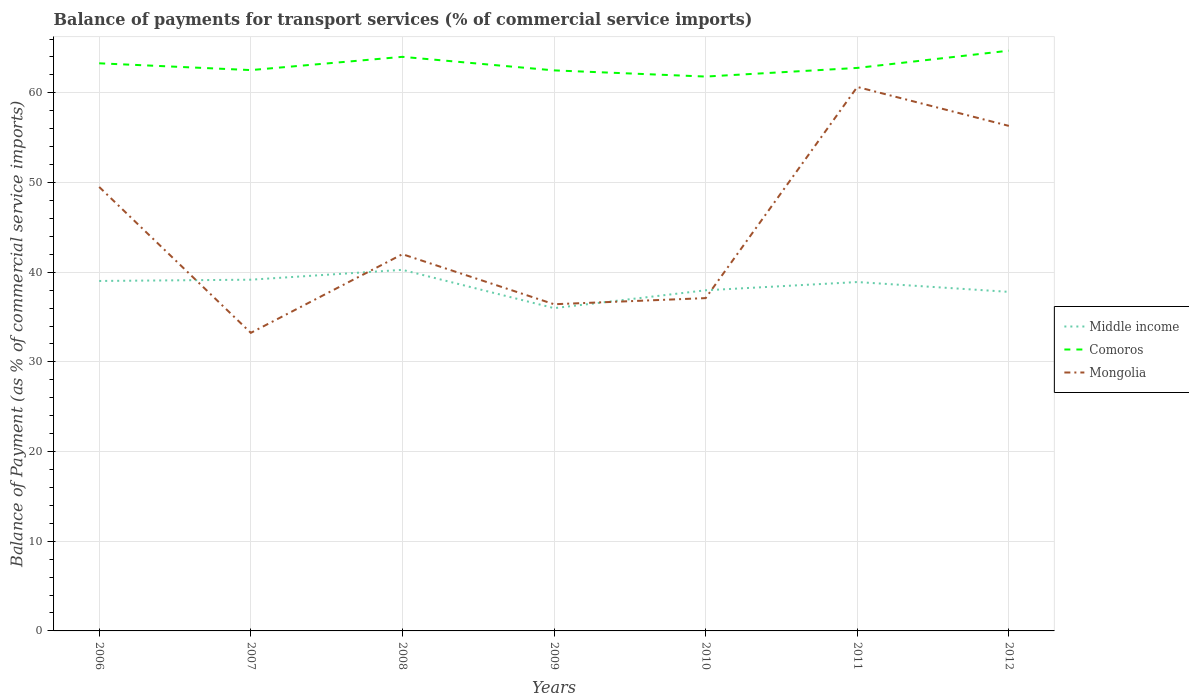How many different coloured lines are there?
Make the answer very short. 3. Does the line corresponding to Comoros intersect with the line corresponding to Mongolia?
Provide a succinct answer. No. Is the number of lines equal to the number of legend labels?
Your response must be concise. Yes. Across all years, what is the maximum balance of payments for transport services in Mongolia?
Ensure brevity in your answer.  33.24. What is the total balance of payments for transport services in Comoros in the graph?
Offer a very short reply. -0.96. What is the difference between the highest and the second highest balance of payments for transport services in Comoros?
Your answer should be very brief. 2.89. What is the difference between the highest and the lowest balance of payments for transport services in Middle income?
Your answer should be very brief. 4. What is the difference between two consecutive major ticks on the Y-axis?
Give a very brief answer. 10. Does the graph contain grids?
Provide a short and direct response. Yes. Where does the legend appear in the graph?
Offer a terse response. Center right. How many legend labels are there?
Give a very brief answer. 3. How are the legend labels stacked?
Your answer should be very brief. Vertical. What is the title of the graph?
Give a very brief answer. Balance of payments for transport services (% of commercial service imports). Does "Croatia" appear as one of the legend labels in the graph?
Your answer should be very brief. No. What is the label or title of the Y-axis?
Offer a very short reply. Balance of Payment (as % of commercial service imports). What is the Balance of Payment (as % of commercial service imports) of Middle income in 2006?
Ensure brevity in your answer.  39.02. What is the Balance of Payment (as % of commercial service imports) in Comoros in 2006?
Provide a short and direct response. 63.3. What is the Balance of Payment (as % of commercial service imports) in Mongolia in 2006?
Make the answer very short. 49.51. What is the Balance of Payment (as % of commercial service imports) of Middle income in 2007?
Provide a short and direct response. 39.17. What is the Balance of Payment (as % of commercial service imports) of Comoros in 2007?
Offer a terse response. 62.54. What is the Balance of Payment (as % of commercial service imports) in Mongolia in 2007?
Your answer should be very brief. 33.24. What is the Balance of Payment (as % of commercial service imports) of Middle income in 2008?
Make the answer very short. 40.27. What is the Balance of Payment (as % of commercial service imports) of Comoros in 2008?
Ensure brevity in your answer.  64.02. What is the Balance of Payment (as % of commercial service imports) of Mongolia in 2008?
Your answer should be very brief. 42.01. What is the Balance of Payment (as % of commercial service imports) in Middle income in 2009?
Provide a short and direct response. 35.99. What is the Balance of Payment (as % of commercial service imports) in Comoros in 2009?
Offer a very short reply. 62.51. What is the Balance of Payment (as % of commercial service imports) of Mongolia in 2009?
Provide a short and direct response. 36.43. What is the Balance of Payment (as % of commercial service imports) of Middle income in 2010?
Make the answer very short. 37.98. What is the Balance of Payment (as % of commercial service imports) in Comoros in 2010?
Ensure brevity in your answer.  61.82. What is the Balance of Payment (as % of commercial service imports) of Mongolia in 2010?
Give a very brief answer. 37.11. What is the Balance of Payment (as % of commercial service imports) in Middle income in 2011?
Provide a short and direct response. 38.9. What is the Balance of Payment (as % of commercial service imports) of Comoros in 2011?
Offer a very short reply. 62.78. What is the Balance of Payment (as % of commercial service imports) of Mongolia in 2011?
Ensure brevity in your answer.  60.66. What is the Balance of Payment (as % of commercial service imports) of Middle income in 2012?
Your response must be concise. 37.81. What is the Balance of Payment (as % of commercial service imports) of Comoros in 2012?
Provide a succinct answer. 64.7. What is the Balance of Payment (as % of commercial service imports) of Mongolia in 2012?
Offer a very short reply. 56.32. Across all years, what is the maximum Balance of Payment (as % of commercial service imports) in Middle income?
Offer a terse response. 40.27. Across all years, what is the maximum Balance of Payment (as % of commercial service imports) of Comoros?
Offer a terse response. 64.7. Across all years, what is the maximum Balance of Payment (as % of commercial service imports) in Mongolia?
Your answer should be very brief. 60.66. Across all years, what is the minimum Balance of Payment (as % of commercial service imports) of Middle income?
Keep it short and to the point. 35.99. Across all years, what is the minimum Balance of Payment (as % of commercial service imports) in Comoros?
Keep it short and to the point. 61.82. Across all years, what is the minimum Balance of Payment (as % of commercial service imports) in Mongolia?
Your response must be concise. 33.24. What is the total Balance of Payment (as % of commercial service imports) in Middle income in the graph?
Provide a succinct answer. 269.14. What is the total Balance of Payment (as % of commercial service imports) in Comoros in the graph?
Provide a succinct answer. 441.66. What is the total Balance of Payment (as % of commercial service imports) in Mongolia in the graph?
Keep it short and to the point. 315.27. What is the difference between the Balance of Payment (as % of commercial service imports) in Middle income in 2006 and that in 2007?
Your response must be concise. -0.14. What is the difference between the Balance of Payment (as % of commercial service imports) in Comoros in 2006 and that in 2007?
Your answer should be very brief. 0.76. What is the difference between the Balance of Payment (as % of commercial service imports) of Mongolia in 2006 and that in 2007?
Give a very brief answer. 16.27. What is the difference between the Balance of Payment (as % of commercial service imports) of Middle income in 2006 and that in 2008?
Offer a very short reply. -1.24. What is the difference between the Balance of Payment (as % of commercial service imports) of Comoros in 2006 and that in 2008?
Your answer should be compact. -0.72. What is the difference between the Balance of Payment (as % of commercial service imports) in Mongolia in 2006 and that in 2008?
Your answer should be very brief. 7.5. What is the difference between the Balance of Payment (as % of commercial service imports) of Middle income in 2006 and that in 2009?
Ensure brevity in your answer.  3.03. What is the difference between the Balance of Payment (as % of commercial service imports) in Comoros in 2006 and that in 2009?
Offer a terse response. 0.79. What is the difference between the Balance of Payment (as % of commercial service imports) of Mongolia in 2006 and that in 2009?
Provide a succinct answer. 13.08. What is the difference between the Balance of Payment (as % of commercial service imports) in Middle income in 2006 and that in 2010?
Offer a very short reply. 1.04. What is the difference between the Balance of Payment (as % of commercial service imports) in Comoros in 2006 and that in 2010?
Make the answer very short. 1.48. What is the difference between the Balance of Payment (as % of commercial service imports) in Mongolia in 2006 and that in 2010?
Offer a very short reply. 12.39. What is the difference between the Balance of Payment (as % of commercial service imports) of Middle income in 2006 and that in 2011?
Provide a succinct answer. 0.12. What is the difference between the Balance of Payment (as % of commercial service imports) in Comoros in 2006 and that in 2011?
Offer a very short reply. 0.52. What is the difference between the Balance of Payment (as % of commercial service imports) of Mongolia in 2006 and that in 2011?
Offer a terse response. -11.15. What is the difference between the Balance of Payment (as % of commercial service imports) in Middle income in 2006 and that in 2012?
Keep it short and to the point. 1.22. What is the difference between the Balance of Payment (as % of commercial service imports) in Comoros in 2006 and that in 2012?
Ensure brevity in your answer.  -1.41. What is the difference between the Balance of Payment (as % of commercial service imports) in Mongolia in 2006 and that in 2012?
Your answer should be very brief. -6.81. What is the difference between the Balance of Payment (as % of commercial service imports) of Middle income in 2007 and that in 2008?
Your answer should be very brief. -1.1. What is the difference between the Balance of Payment (as % of commercial service imports) in Comoros in 2007 and that in 2008?
Ensure brevity in your answer.  -1.48. What is the difference between the Balance of Payment (as % of commercial service imports) in Mongolia in 2007 and that in 2008?
Make the answer very short. -8.77. What is the difference between the Balance of Payment (as % of commercial service imports) of Middle income in 2007 and that in 2009?
Your answer should be compact. 3.17. What is the difference between the Balance of Payment (as % of commercial service imports) of Comoros in 2007 and that in 2009?
Offer a very short reply. 0.03. What is the difference between the Balance of Payment (as % of commercial service imports) in Mongolia in 2007 and that in 2009?
Offer a terse response. -3.19. What is the difference between the Balance of Payment (as % of commercial service imports) of Middle income in 2007 and that in 2010?
Keep it short and to the point. 1.18. What is the difference between the Balance of Payment (as % of commercial service imports) of Comoros in 2007 and that in 2010?
Offer a very short reply. 0.72. What is the difference between the Balance of Payment (as % of commercial service imports) of Mongolia in 2007 and that in 2010?
Your answer should be very brief. -3.87. What is the difference between the Balance of Payment (as % of commercial service imports) in Middle income in 2007 and that in 2011?
Offer a terse response. 0.26. What is the difference between the Balance of Payment (as % of commercial service imports) in Comoros in 2007 and that in 2011?
Give a very brief answer. -0.24. What is the difference between the Balance of Payment (as % of commercial service imports) of Mongolia in 2007 and that in 2011?
Offer a very short reply. -27.42. What is the difference between the Balance of Payment (as % of commercial service imports) of Middle income in 2007 and that in 2012?
Provide a succinct answer. 1.36. What is the difference between the Balance of Payment (as % of commercial service imports) of Comoros in 2007 and that in 2012?
Your response must be concise. -2.16. What is the difference between the Balance of Payment (as % of commercial service imports) of Mongolia in 2007 and that in 2012?
Your answer should be compact. -23.08. What is the difference between the Balance of Payment (as % of commercial service imports) of Middle income in 2008 and that in 2009?
Give a very brief answer. 4.27. What is the difference between the Balance of Payment (as % of commercial service imports) of Comoros in 2008 and that in 2009?
Ensure brevity in your answer.  1.51. What is the difference between the Balance of Payment (as % of commercial service imports) in Mongolia in 2008 and that in 2009?
Your answer should be very brief. 5.58. What is the difference between the Balance of Payment (as % of commercial service imports) of Middle income in 2008 and that in 2010?
Make the answer very short. 2.28. What is the difference between the Balance of Payment (as % of commercial service imports) in Comoros in 2008 and that in 2010?
Provide a succinct answer. 2.2. What is the difference between the Balance of Payment (as % of commercial service imports) of Mongolia in 2008 and that in 2010?
Make the answer very short. 4.9. What is the difference between the Balance of Payment (as % of commercial service imports) of Middle income in 2008 and that in 2011?
Provide a short and direct response. 1.36. What is the difference between the Balance of Payment (as % of commercial service imports) of Comoros in 2008 and that in 2011?
Provide a short and direct response. 1.24. What is the difference between the Balance of Payment (as % of commercial service imports) in Mongolia in 2008 and that in 2011?
Provide a succinct answer. -18.65. What is the difference between the Balance of Payment (as % of commercial service imports) of Middle income in 2008 and that in 2012?
Your answer should be very brief. 2.46. What is the difference between the Balance of Payment (as % of commercial service imports) in Comoros in 2008 and that in 2012?
Offer a terse response. -0.69. What is the difference between the Balance of Payment (as % of commercial service imports) in Mongolia in 2008 and that in 2012?
Your answer should be very brief. -14.31. What is the difference between the Balance of Payment (as % of commercial service imports) of Middle income in 2009 and that in 2010?
Provide a succinct answer. -1.99. What is the difference between the Balance of Payment (as % of commercial service imports) in Comoros in 2009 and that in 2010?
Ensure brevity in your answer.  0.69. What is the difference between the Balance of Payment (as % of commercial service imports) of Mongolia in 2009 and that in 2010?
Keep it short and to the point. -0.68. What is the difference between the Balance of Payment (as % of commercial service imports) in Middle income in 2009 and that in 2011?
Ensure brevity in your answer.  -2.91. What is the difference between the Balance of Payment (as % of commercial service imports) of Comoros in 2009 and that in 2011?
Give a very brief answer. -0.27. What is the difference between the Balance of Payment (as % of commercial service imports) in Mongolia in 2009 and that in 2011?
Your response must be concise. -24.23. What is the difference between the Balance of Payment (as % of commercial service imports) of Middle income in 2009 and that in 2012?
Your answer should be compact. -1.81. What is the difference between the Balance of Payment (as % of commercial service imports) in Comoros in 2009 and that in 2012?
Your answer should be compact. -2.2. What is the difference between the Balance of Payment (as % of commercial service imports) in Mongolia in 2009 and that in 2012?
Your response must be concise. -19.89. What is the difference between the Balance of Payment (as % of commercial service imports) in Middle income in 2010 and that in 2011?
Make the answer very short. -0.92. What is the difference between the Balance of Payment (as % of commercial service imports) in Comoros in 2010 and that in 2011?
Your response must be concise. -0.96. What is the difference between the Balance of Payment (as % of commercial service imports) of Mongolia in 2010 and that in 2011?
Keep it short and to the point. -23.55. What is the difference between the Balance of Payment (as % of commercial service imports) of Middle income in 2010 and that in 2012?
Make the answer very short. 0.18. What is the difference between the Balance of Payment (as % of commercial service imports) of Comoros in 2010 and that in 2012?
Your answer should be compact. -2.89. What is the difference between the Balance of Payment (as % of commercial service imports) in Mongolia in 2010 and that in 2012?
Your response must be concise. -19.21. What is the difference between the Balance of Payment (as % of commercial service imports) in Middle income in 2011 and that in 2012?
Provide a succinct answer. 1.1. What is the difference between the Balance of Payment (as % of commercial service imports) of Comoros in 2011 and that in 2012?
Give a very brief answer. -1.92. What is the difference between the Balance of Payment (as % of commercial service imports) of Mongolia in 2011 and that in 2012?
Your answer should be very brief. 4.34. What is the difference between the Balance of Payment (as % of commercial service imports) of Middle income in 2006 and the Balance of Payment (as % of commercial service imports) of Comoros in 2007?
Provide a short and direct response. -23.52. What is the difference between the Balance of Payment (as % of commercial service imports) in Middle income in 2006 and the Balance of Payment (as % of commercial service imports) in Mongolia in 2007?
Provide a short and direct response. 5.79. What is the difference between the Balance of Payment (as % of commercial service imports) of Comoros in 2006 and the Balance of Payment (as % of commercial service imports) of Mongolia in 2007?
Your answer should be compact. 30.06. What is the difference between the Balance of Payment (as % of commercial service imports) in Middle income in 2006 and the Balance of Payment (as % of commercial service imports) in Comoros in 2008?
Offer a very short reply. -24.99. What is the difference between the Balance of Payment (as % of commercial service imports) of Middle income in 2006 and the Balance of Payment (as % of commercial service imports) of Mongolia in 2008?
Your answer should be very brief. -2.98. What is the difference between the Balance of Payment (as % of commercial service imports) in Comoros in 2006 and the Balance of Payment (as % of commercial service imports) in Mongolia in 2008?
Ensure brevity in your answer.  21.29. What is the difference between the Balance of Payment (as % of commercial service imports) of Middle income in 2006 and the Balance of Payment (as % of commercial service imports) of Comoros in 2009?
Offer a very short reply. -23.48. What is the difference between the Balance of Payment (as % of commercial service imports) in Middle income in 2006 and the Balance of Payment (as % of commercial service imports) in Mongolia in 2009?
Keep it short and to the point. 2.6. What is the difference between the Balance of Payment (as % of commercial service imports) in Comoros in 2006 and the Balance of Payment (as % of commercial service imports) in Mongolia in 2009?
Give a very brief answer. 26.87. What is the difference between the Balance of Payment (as % of commercial service imports) of Middle income in 2006 and the Balance of Payment (as % of commercial service imports) of Comoros in 2010?
Your response must be concise. -22.79. What is the difference between the Balance of Payment (as % of commercial service imports) of Middle income in 2006 and the Balance of Payment (as % of commercial service imports) of Mongolia in 2010?
Give a very brief answer. 1.91. What is the difference between the Balance of Payment (as % of commercial service imports) in Comoros in 2006 and the Balance of Payment (as % of commercial service imports) in Mongolia in 2010?
Provide a short and direct response. 26.18. What is the difference between the Balance of Payment (as % of commercial service imports) of Middle income in 2006 and the Balance of Payment (as % of commercial service imports) of Comoros in 2011?
Give a very brief answer. -23.76. What is the difference between the Balance of Payment (as % of commercial service imports) of Middle income in 2006 and the Balance of Payment (as % of commercial service imports) of Mongolia in 2011?
Ensure brevity in your answer.  -21.63. What is the difference between the Balance of Payment (as % of commercial service imports) in Comoros in 2006 and the Balance of Payment (as % of commercial service imports) in Mongolia in 2011?
Make the answer very short. 2.64. What is the difference between the Balance of Payment (as % of commercial service imports) of Middle income in 2006 and the Balance of Payment (as % of commercial service imports) of Comoros in 2012?
Offer a terse response. -25.68. What is the difference between the Balance of Payment (as % of commercial service imports) in Middle income in 2006 and the Balance of Payment (as % of commercial service imports) in Mongolia in 2012?
Give a very brief answer. -17.29. What is the difference between the Balance of Payment (as % of commercial service imports) in Comoros in 2006 and the Balance of Payment (as % of commercial service imports) in Mongolia in 2012?
Make the answer very short. 6.98. What is the difference between the Balance of Payment (as % of commercial service imports) of Middle income in 2007 and the Balance of Payment (as % of commercial service imports) of Comoros in 2008?
Provide a succinct answer. -24.85. What is the difference between the Balance of Payment (as % of commercial service imports) of Middle income in 2007 and the Balance of Payment (as % of commercial service imports) of Mongolia in 2008?
Your answer should be compact. -2.84. What is the difference between the Balance of Payment (as % of commercial service imports) in Comoros in 2007 and the Balance of Payment (as % of commercial service imports) in Mongolia in 2008?
Ensure brevity in your answer.  20.53. What is the difference between the Balance of Payment (as % of commercial service imports) in Middle income in 2007 and the Balance of Payment (as % of commercial service imports) in Comoros in 2009?
Keep it short and to the point. -23.34. What is the difference between the Balance of Payment (as % of commercial service imports) in Middle income in 2007 and the Balance of Payment (as % of commercial service imports) in Mongolia in 2009?
Offer a terse response. 2.74. What is the difference between the Balance of Payment (as % of commercial service imports) in Comoros in 2007 and the Balance of Payment (as % of commercial service imports) in Mongolia in 2009?
Offer a terse response. 26.11. What is the difference between the Balance of Payment (as % of commercial service imports) in Middle income in 2007 and the Balance of Payment (as % of commercial service imports) in Comoros in 2010?
Keep it short and to the point. -22.65. What is the difference between the Balance of Payment (as % of commercial service imports) in Middle income in 2007 and the Balance of Payment (as % of commercial service imports) in Mongolia in 2010?
Make the answer very short. 2.05. What is the difference between the Balance of Payment (as % of commercial service imports) of Comoros in 2007 and the Balance of Payment (as % of commercial service imports) of Mongolia in 2010?
Provide a succinct answer. 25.43. What is the difference between the Balance of Payment (as % of commercial service imports) in Middle income in 2007 and the Balance of Payment (as % of commercial service imports) in Comoros in 2011?
Provide a succinct answer. -23.61. What is the difference between the Balance of Payment (as % of commercial service imports) of Middle income in 2007 and the Balance of Payment (as % of commercial service imports) of Mongolia in 2011?
Ensure brevity in your answer.  -21.49. What is the difference between the Balance of Payment (as % of commercial service imports) in Comoros in 2007 and the Balance of Payment (as % of commercial service imports) in Mongolia in 2011?
Offer a very short reply. 1.88. What is the difference between the Balance of Payment (as % of commercial service imports) of Middle income in 2007 and the Balance of Payment (as % of commercial service imports) of Comoros in 2012?
Offer a terse response. -25.54. What is the difference between the Balance of Payment (as % of commercial service imports) of Middle income in 2007 and the Balance of Payment (as % of commercial service imports) of Mongolia in 2012?
Provide a short and direct response. -17.15. What is the difference between the Balance of Payment (as % of commercial service imports) of Comoros in 2007 and the Balance of Payment (as % of commercial service imports) of Mongolia in 2012?
Offer a terse response. 6.22. What is the difference between the Balance of Payment (as % of commercial service imports) of Middle income in 2008 and the Balance of Payment (as % of commercial service imports) of Comoros in 2009?
Ensure brevity in your answer.  -22.24. What is the difference between the Balance of Payment (as % of commercial service imports) in Middle income in 2008 and the Balance of Payment (as % of commercial service imports) in Mongolia in 2009?
Keep it short and to the point. 3.84. What is the difference between the Balance of Payment (as % of commercial service imports) of Comoros in 2008 and the Balance of Payment (as % of commercial service imports) of Mongolia in 2009?
Your response must be concise. 27.59. What is the difference between the Balance of Payment (as % of commercial service imports) in Middle income in 2008 and the Balance of Payment (as % of commercial service imports) in Comoros in 2010?
Provide a succinct answer. -21.55. What is the difference between the Balance of Payment (as % of commercial service imports) of Middle income in 2008 and the Balance of Payment (as % of commercial service imports) of Mongolia in 2010?
Offer a very short reply. 3.15. What is the difference between the Balance of Payment (as % of commercial service imports) in Comoros in 2008 and the Balance of Payment (as % of commercial service imports) in Mongolia in 2010?
Your answer should be compact. 26.91. What is the difference between the Balance of Payment (as % of commercial service imports) of Middle income in 2008 and the Balance of Payment (as % of commercial service imports) of Comoros in 2011?
Keep it short and to the point. -22.52. What is the difference between the Balance of Payment (as % of commercial service imports) in Middle income in 2008 and the Balance of Payment (as % of commercial service imports) in Mongolia in 2011?
Give a very brief answer. -20.39. What is the difference between the Balance of Payment (as % of commercial service imports) in Comoros in 2008 and the Balance of Payment (as % of commercial service imports) in Mongolia in 2011?
Ensure brevity in your answer.  3.36. What is the difference between the Balance of Payment (as % of commercial service imports) of Middle income in 2008 and the Balance of Payment (as % of commercial service imports) of Comoros in 2012?
Ensure brevity in your answer.  -24.44. What is the difference between the Balance of Payment (as % of commercial service imports) in Middle income in 2008 and the Balance of Payment (as % of commercial service imports) in Mongolia in 2012?
Your answer should be compact. -16.05. What is the difference between the Balance of Payment (as % of commercial service imports) in Comoros in 2008 and the Balance of Payment (as % of commercial service imports) in Mongolia in 2012?
Keep it short and to the point. 7.7. What is the difference between the Balance of Payment (as % of commercial service imports) in Middle income in 2009 and the Balance of Payment (as % of commercial service imports) in Comoros in 2010?
Your answer should be very brief. -25.82. What is the difference between the Balance of Payment (as % of commercial service imports) of Middle income in 2009 and the Balance of Payment (as % of commercial service imports) of Mongolia in 2010?
Provide a short and direct response. -1.12. What is the difference between the Balance of Payment (as % of commercial service imports) of Comoros in 2009 and the Balance of Payment (as % of commercial service imports) of Mongolia in 2010?
Your answer should be compact. 25.39. What is the difference between the Balance of Payment (as % of commercial service imports) of Middle income in 2009 and the Balance of Payment (as % of commercial service imports) of Comoros in 2011?
Offer a terse response. -26.79. What is the difference between the Balance of Payment (as % of commercial service imports) of Middle income in 2009 and the Balance of Payment (as % of commercial service imports) of Mongolia in 2011?
Your answer should be very brief. -24.66. What is the difference between the Balance of Payment (as % of commercial service imports) in Comoros in 2009 and the Balance of Payment (as % of commercial service imports) in Mongolia in 2011?
Your answer should be compact. 1.85. What is the difference between the Balance of Payment (as % of commercial service imports) in Middle income in 2009 and the Balance of Payment (as % of commercial service imports) in Comoros in 2012?
Make the answer very short. -28.71. What is the difference between the Balance of Payment (as % of commercial service imports) in Middle income in 2009 and the Balance of Payment (as % of commercial service imports) in Mongolia in 2012?
Provide a succinct answer. -20.32. What is the difference between the Balance of Payment (as % of commercial service imports) in Comoros in 2009 and the Balance of Payment (as % of commercial service imports) in Mongolia in 2012?
Make the answer very short. 6.19. What is the difference between the Balance of Payment (as % of commercial service imports) of Middle income in 2010 and the Balance of Payment (as % of commercial service imports) of Comoros in 2011?
Give a very brief answer. -24.8. What is the difference between the Balance of Payment (as % of commercial service imports) of Middle income in 2010 and the Balance of Payment (as % of commercial service imports) of Mongolia in 2011?
Your answer should be very brief. -22.67. What is the difference between the Balance of Payment (as % of commercial service imports) in Comoros in 2010 and the Balance of Payment (as % of commercial service imports) in Mongolia in 2011?
Your answer should be very brief. 1.16. What is the difference between the Balance of Payment (as % of commercial service imports) in Middle income in 2010 and the Balance of Payment (as % of commercial service imports) in Comoros in 2012?
Give a very brief answer. -26.72. What is the difference between the Balance of Payment (as % of commercial service imports) of Middle income in 2010 and the Balance of Payment (as % of commercial service imports) of Mongolia in 2012?
Give a very brief answer. -18.33. What is the difference between the Balance of Payment (as % of commercial service imports) of Comoros in 2010 and the Balance of Payment (as % of commercial service imports) of Mongolia in 2012?
Provide a short and direct response. 5.5. What is the difference between the Balance of Payment (as % of commercial service imports) in Middle income in 2011 and the Balance of Payment (as % of commercial service imports) in Comoros in 2012?
Give a very brief answer. -25.8. What is the difference between the Balance of Payment (as % of commercial service imports) of Middle income in 2011 and the Balance of Payment (as % of commercial service imports) of Mongolia in 2012?
Keep it short and to the point. -17.41. What is the difference between the Balance of Payment (as % of commercial service imports) in Comoros in 2011 and the Balance of Payment (as % of commercial service imports) in Mongolia in 2012?
Your response must be concise. 6.46. What is the average Balance of Payment (as % of commercial service imports) in Middle income per year?
Give a very brief answer. 38.45. What is the average Balance of Payment (as % of commercial service imports) in Comoros per year?
Provide a short and direct response. 63.09. What is the average Balance of Payment (as % of commercial service imports) of Mongolia per year?
Keep it short and to the point. 45.04. In the year 2006, what is the difference between the Balance of Payment (as % of commercial service imports) of Middle income and Balance of Payment (as % of commercial service imports) of Comoros?
Ensure brevity in your answer.  -24.27. In the year 2006, what is the difference between the Balance of Payment (as % of commercial service imports) in Middle income and Balance of Payment (as % of commercial service imports) in Mongolia?
Offer a terse response. -10.48. In the year 2006, what is the difference between the Balance of Payment (as % of commercial service imports) of Comoros and Balance of Payment (as % of commercial service imports) of Mongolia?
Your response must be concise. 13.79. In the year 2007, what is the difference between the Balance of Payment (as % of commercial service imports) of Middle income and Balance of Payment (as % of commercial service imports) of Comoros?
Your answer should be very brief. -23.37. In the year 2007, what is the difference between the Balance of Payment (as % of commercial service imports) in Middle income and Balance of Payment (as % of commercial service imports) in Mongolia?
Keep it short and to the point. 5.93. In the year 2007, what is the difference between the Balance of Payment (as % of commercial service imports) of Comoros and Balance of Payment (as % of commercial service imports) of Mongolia?
Your response must be concise. 29.3. In the year 2008, what is the difference between the Balance of Payment (as % of commercial service imports) in Middle income and Balance of Payment (as % of commercial service imports) in Comoros?
Provide a succinct answer. -23.75. In the year 2008, what is the difference between the Balance of Payment (as % of commercial service imports) of Middle income and Balance of Payment (as % of commercial service imports) of Mongolia?
Your answer should be compact. -1.74. In the year 2008, what is the difference between the Balance of Payment (as % of commercial service imports) in Comoros and Balance of Payment (as % of commercial service imports) in Mongolia?
Give a very brief answer. 22.01. In the year 2009, what is the difference between the Balance of Payment (as % of commercial service imports) of Middle income and Balance of Payment (as % of commercial service imports) of Comoros?
Your response must be concise. -26.51. In the year 2009, what is the difference between the Balance of Payment (as % of commercial service imports) in Middle income and Balance of Payment (as % of commercial service imports) in Mongolia?
Ensure brevity in your answer.  -0.44. In the year 2009, what is the difference between the Balance of Payment (as % of commercial service imports) of Comoros and Balance of Payment (as % of commercial service imports) of Mongolia?
Provide a succinct answer. 26.08. In the year 2010, what is the difference between the Balance of Payment (as % of commercial service imports) in Middle income and Balance of Payment (as % of commercial service imports) in Comoros?
Give a very brief answer. -23.83. In the year 2010, what is the difference between the Balance of Payment (as % of commercial service imports) of Middle income and Balance of Payment (as % of commercial service imports) of Mongolia?
Provide a short and direct response. 0.87. In the year 2010, what is the difference between the Balance of Payment (as % of commercial service imports) of Comoros and Balance of Payment (as % of commercial service imports) of Mongolia?
Offer a very short reply. 24.71. In the year 2011, what is the difference between the Balance of Payment (as % of commercial service imports) in Middle income and Balance of Payment (as % of commercial service imports) in Comoros?
Provide a short and direct response. -23.88. In the year 2011, what is the difference between the Balance of Payment (as % of commercial service imports) of Middle income and Balance of Payment (as % of commercial service imports) of Mongolia?
Offer a terse response. -21.75. In the year 2011, what is the difference between the Balance of Payment (as % of commercial service imports) in Comoros and Balance of Payment (as % of commercial service imports) in Mongolia?
Offer a terse response. 2.12. In the year 2012, what is the difference between the Balance of Payment (as % of commercial service imports) of Middle income and Balance of Payment (as % of commercial service imports) of Comoros?
Your answer should be very brief. -26.9. In the year 2012, what is the difference between the Balance of Payment (as % of commercial service imports) of Middle income and Balance of Payment (as % of commercial service imports) of Mongolia?
Provide a succinct answer. -18.51. In the year 2012, what is the difference between the Balance of Payment (as % of commercial service imports) of Comoros and Balance of Payment (as % of commercial service imports) of Mongolia?
Make the answer very short. 8.39. What is the ratio of the Balance of Payment (as % of commercial service imports) of Middle income in 2006 to that in 2007?
Offer a very short reply. 1. What is the ratio of the Balance of Payment (as % of commercial service imports) of Comoros in 2006 to that in 2007?
Provide a short and direct response. 1.01. What is the ratio of the Balance of Payment (as % of commercial service imports) in Mongolia in 2006 to that in 2007?
Your answer should be very brief. 1.49. What is the ratio of the Balance of Payment (as % of commercial service imports) of Middle income in 2006 to that in 2008?
Your response must be concise. 0.97. What is the ratio of the Balance of Payment (as % of commercial service imports) in Comoros in 2006 to that in 2008?
Your response must be concise. 0.99. What is the ratio of the Balance of Payment (as % of commercial service imports) of Mongolia in 2006 to that in 2008?
Provide a succinct answer. 1.18. What is the ratio of the Balance of Payment (as % of commercial service imports) of Middle income in 2006 to that in 2009?
Make the answer very short. 1.08. What is the ratio of the Balance of Payment (as % of commercial service imports) of Comoros in 2006 to that in 2009?
Your answer should be very brief. 1.01. What is the ratio of the Balance of Payment (as % of commercial service imports) of Mongolia in 2006 to that in 2009?
Provide a short and direct response. 1.36. What is the ratio of the Balance of Payment (as % of commercial service imports) in Middle income in 2006 to that in 2010?
Keep it short and to the point. 1.03. What is the ratio of the Balance of Payment (as % of commercial service imports) of Comoros in 2006 to that in 2010?
Make the answer very short. 1.02. What is the ratio of the Balance of Payment (as % of commercial service imports) of Mongolia in 2006 to that in 2010?
Provide a succinct answer. 1.33. What is the ratio of the Balance of Payment (as % of commercial service imports) of Middle income in 2006 to that in 2011?
Ensure brevity in your answer.  1. What is the ratio of the Balance of Payment (as % of commercial service imports) in Comoros in 2006 to that in 2011?
Your answer should be compact. 1.01. What is the ratio of the Balance of Payment (as % of commercial service imports) in Mongolia in 2006 to that in 2011?
Offer a terse response. 0.82. What is the ratio of the Balance of Payment (as % of commercial service imports) in Middle income in 2006 to that in 2012?
Ensure brevity in your answer.  1.03. What is the ratio of the Balance of Payment (as % of commercial service imports) of Comoros in 2006 to that in 2012?
Your answer should be very brief. 0.98. What is the ratio of the Balance of Payment (as % of commercial service imports) in Mongolia in 2006 to that in 2012?
Your answer should be very brief. 0.88. What is the ratio of the Balance of Payment (as % of commercial service imports) of Middle income in 2007 to that in 2008?
Ensure brevity in your answer.  0.97. What is the ratio of the Balance of Payment (as % of commercial service imports) in Comoros in 2007 to that in 2008?
Provide a succinct answer. 0.98. What is the ratio of the Balance of Payment (as % of commercial service imports) in Mongolia in 2007 to that in 2008?
Your answer should be very brief. 0.79. What is the ratio of the Balance of Payment (as % of commercial service imports) of Middle income in 2007 to that in 2009?
Keep it short and to the point. 1.09. What is the ratio of the Balance of Payment (as % of commercial service imports) of Comoros in 2007 to that in 2009?
Ensure brevity in your answer.  1. What is the ratio of the Balance of Payment (as % of commercial service imports) of Mongolia in 2007 to that in 2009?
Offer a very short reply. 0.91. What is the ratio of the Balance of Payment (as % of commercial service imports) in Middle income in 2007 to that in 2010?
Offer a very short reply. 1.03. What is the ratio of the Balance of Payment (as % of commercial service imports) in Comoros in 2007 to that in 2010?
Your response must be concise. 1.01. What is the ratio of the Balance of Payment (as % of commercial service imports) in Mongolia in 2007 to that in 2010?
Your answer should be compact. 0.9. What is the ratio of the Balance of Payment (as % of commercial service imports) of Middle income in 2007 to that in 2011?
Your answer should be compact. 1.01. What is the ratio of the Balance of Payment (as % of commercial service imports) of Comoros in 2007 to that in 2011?
Keep it short and to the point. 1. What is the ratio of the Balance of Payment (as % of commercial service imports) of Mongolia in 2007 to that in 2011?
Offer a terse response. 0.55. What is the ratio of the Balance of Payment (as % of commercial service imports) of Middle income in 2007 to that in 2012?
Provide a succinct answer. 1.04. What is the ratio of the Balance of Payment (as % of commercial service imports) in Comoros in 2007 to that in 2012?
Keep it short and to the point. 0.97. What is the ratio of the Balance of Payment (as % of commercial service imports) of Mongolia in 2007 to that in 2012?
Offer a very short reply. 0.59. What is the ratio of the Balance of Payment (as % of commercial service imports) in Middle income in 2008 to that in 2009?
Make the answer very short. 1.12. What is the ratio of the Balance of Payment (as % of commercial service imports) in Comoros in 2008 to that in 2009?
Offer a very short reply. 1.02. What is the ratio of the Balance of Payment (as % of commercial service imports) in Mongolia in 2008 to that in 2009?
Ensure brevity in your answer.  1.15. What is the ratio of the Balance of Payment (as % of commercial service imports) of Middle income in 2008 to that in 2010?
Make the answer very short. 1.06. What is the ratio of the Balance of Payment (as % of commercial service imports) of Comoros in 2008 to that in 2010?
Your response must be concise. 1.04. What is the ratio of the Balance of Payment (as % of commercial service imports) of Mongolia in 2008 to that in 2010?
Provide a short and direct response. 1.13. What is the ratio of the Balance of Payment (as % of commercial service imports) of Middle income in 2008 to that in 2011?
Provide a short and direct response. 1.03. What is the ratio of the Balance of Payment (as % of commercial service imports) in Comoros in 2008 to that in 2011?
Your response must be concise. 1.02. What is the ratio of the Balance of Payment (as % of commercial service imports) in Mongolia in 2008 to that in 2011?
Offer a very short reply. 0.69. What is the ratio of the Balance of Payment (as % of commercial service imports) in Middle income in 2008 to that in 2012?
Your answer should be compact. 1.06. What is the ratio of the Balance of Payment (as % of commercial service imports) in Mongolia in 2008 to that in 2012?
Give a very brief answer. 0.75. What is the ratio of the Balance of Payment (as % of commercial service imports) of Middle income in 2009 to that in 2010?
Provide a succinct answer. 0.95. What is the ratio of the Balance of Payment (as % of commercial service imports) of Comoros in 2009 to that in 2010?
Your answer should be compact. 1.01. What is the ratio of the Balance of Payment (as % of commercial service imports) in Mongolia in 2009 to that in 2010?
Provide a succinct answer. 0.98. What is the ratio of the Balance of Payment (as % of commercial service imports) in Middle income in 2009 to that in 2011?
Offer a very short reply. 0.93. What is the ratio of the Balance of Payment (as % of commercial service imports) in Comoros in 2009 to that in 2011?
Offer a terse response. 1. What is the ratio of the Balance of Payment (as % of commercial service imports) of Mongolia in 2009 to that in 2011?
Keep it short and to the point. 0.6. What is the ratio of the Balance of Payment (as % of commercial service imports) in Middle income in 2009 to that in 2012?
Your answer should be compact. 0.95. What is the ratio of the Balance of Payment (as % of commercial service imports) in Mongolia in 2009 to that in 2012?
Offer a very short reply. 0.65. What is the ratio of the Balance of Payment (as % of commercial service imports) of Middle income in 2010 to that in 2011?
Give a very brief answer. 0.98. What is the ratio of the Balance of Payment (as % of commercial service imports) of Comoros in 2010 to that in 2011?
Make the answer very short. 0.98. What is the ratio of the Balance of Payment (as % of commercial service imports) of Mongolia in 2010 to that in 2011?
Your response must be concise. 0.61. What is the ratio of the Balance of Payment (as % of commercial service imports) in Middle income in 2010 to that in 2012?
Make the answer very short. 1. What is the ratio of the Balance of Payment (as % of commercial service imports) of Comoros in 2010 to that in 2012?
Your answer should be compact. 0.96. What is the ratio of the Balance of Payment (as % of commercial service imports) of Mongolia in 2010 to that in 2012?
Keep it short and to the point. 0.66. What is the ratio of the Balance of Payment (as % of commercial service imports) of Middle income in 2011 to that in 2012?
Make the answer very short. 1.03. What is the ratio of the Balance of Payment (as % of commercial service imports) in Comoros in 2011 to that in 2012?
Make the answer very short. 0.97. What is the ratio of the Balance of Payment (as % of commercial service imports) in Mongolia in 2011 to that in 2012?
Ensure brevity in your answer.  1.08. What is the difference between the highest and the second highest Balance of Payment (as % of commercial service imports) in Middle income?
Ensure brevity in your answer.  1.1. What is the difference between the highest and the second highest Balance of Payment (as % of commercial service imports) in Comoros?
Make the answer very short. 0.69. What is the difference between the highest and the second highest Balance of Payment (as % of commercial service imports) of Mongolia?
Keep it short and to the point. 4.34. What is the difference between the highest and the lowest Balance of Payment (as % of commercial service imports) in Middle income?
Offer a terse response. 4.27. What is the difference between the highest and the lowest Balance of Payment (as % of commercial service imports) of Comoros?
Offer a terse response. 2.89. What is the difference between the highest and the lowest Balance of Payment (as % of commercial service imports) of Mongolia?
Provide a succinct answer. 27.42. 